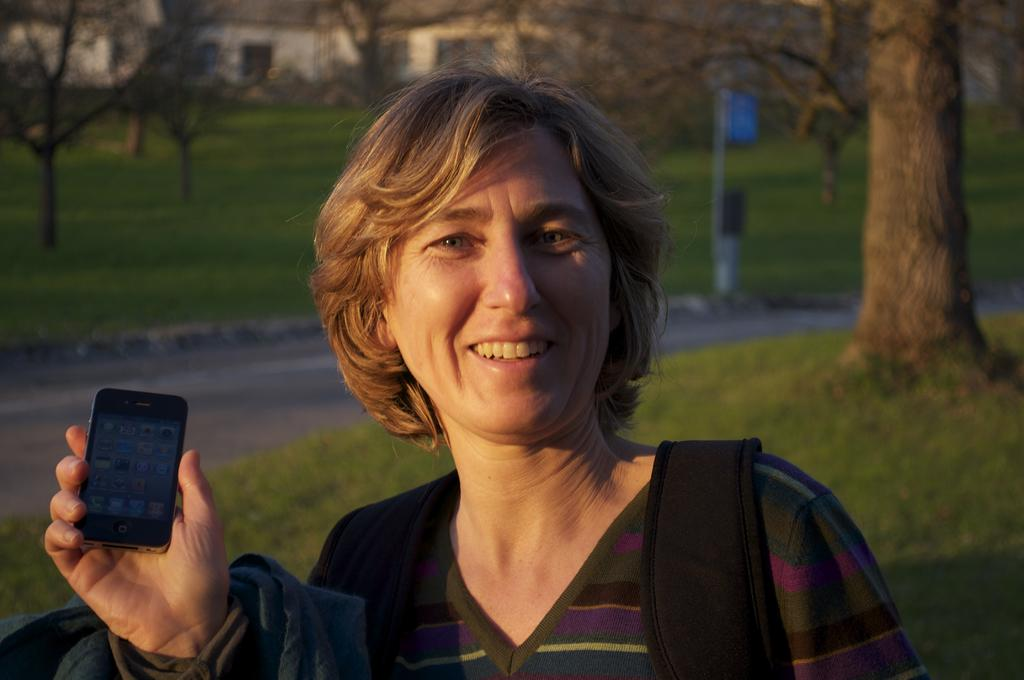Who is present in the image? There is a woman in the image. What is the woman holding in the image? The woman is holding a mobile in the image. What is the woman wearing in the image? The woman is wearing a bag in the image. What is the color of the grass in the image? The grass is green in color in the image. What can be seen in the distance in the image? There are bare trees and a building in the distance in the image. How many tomatoes are being sold for profit in the image? There are no tomatoes or any indication of selling or profit in the image. 